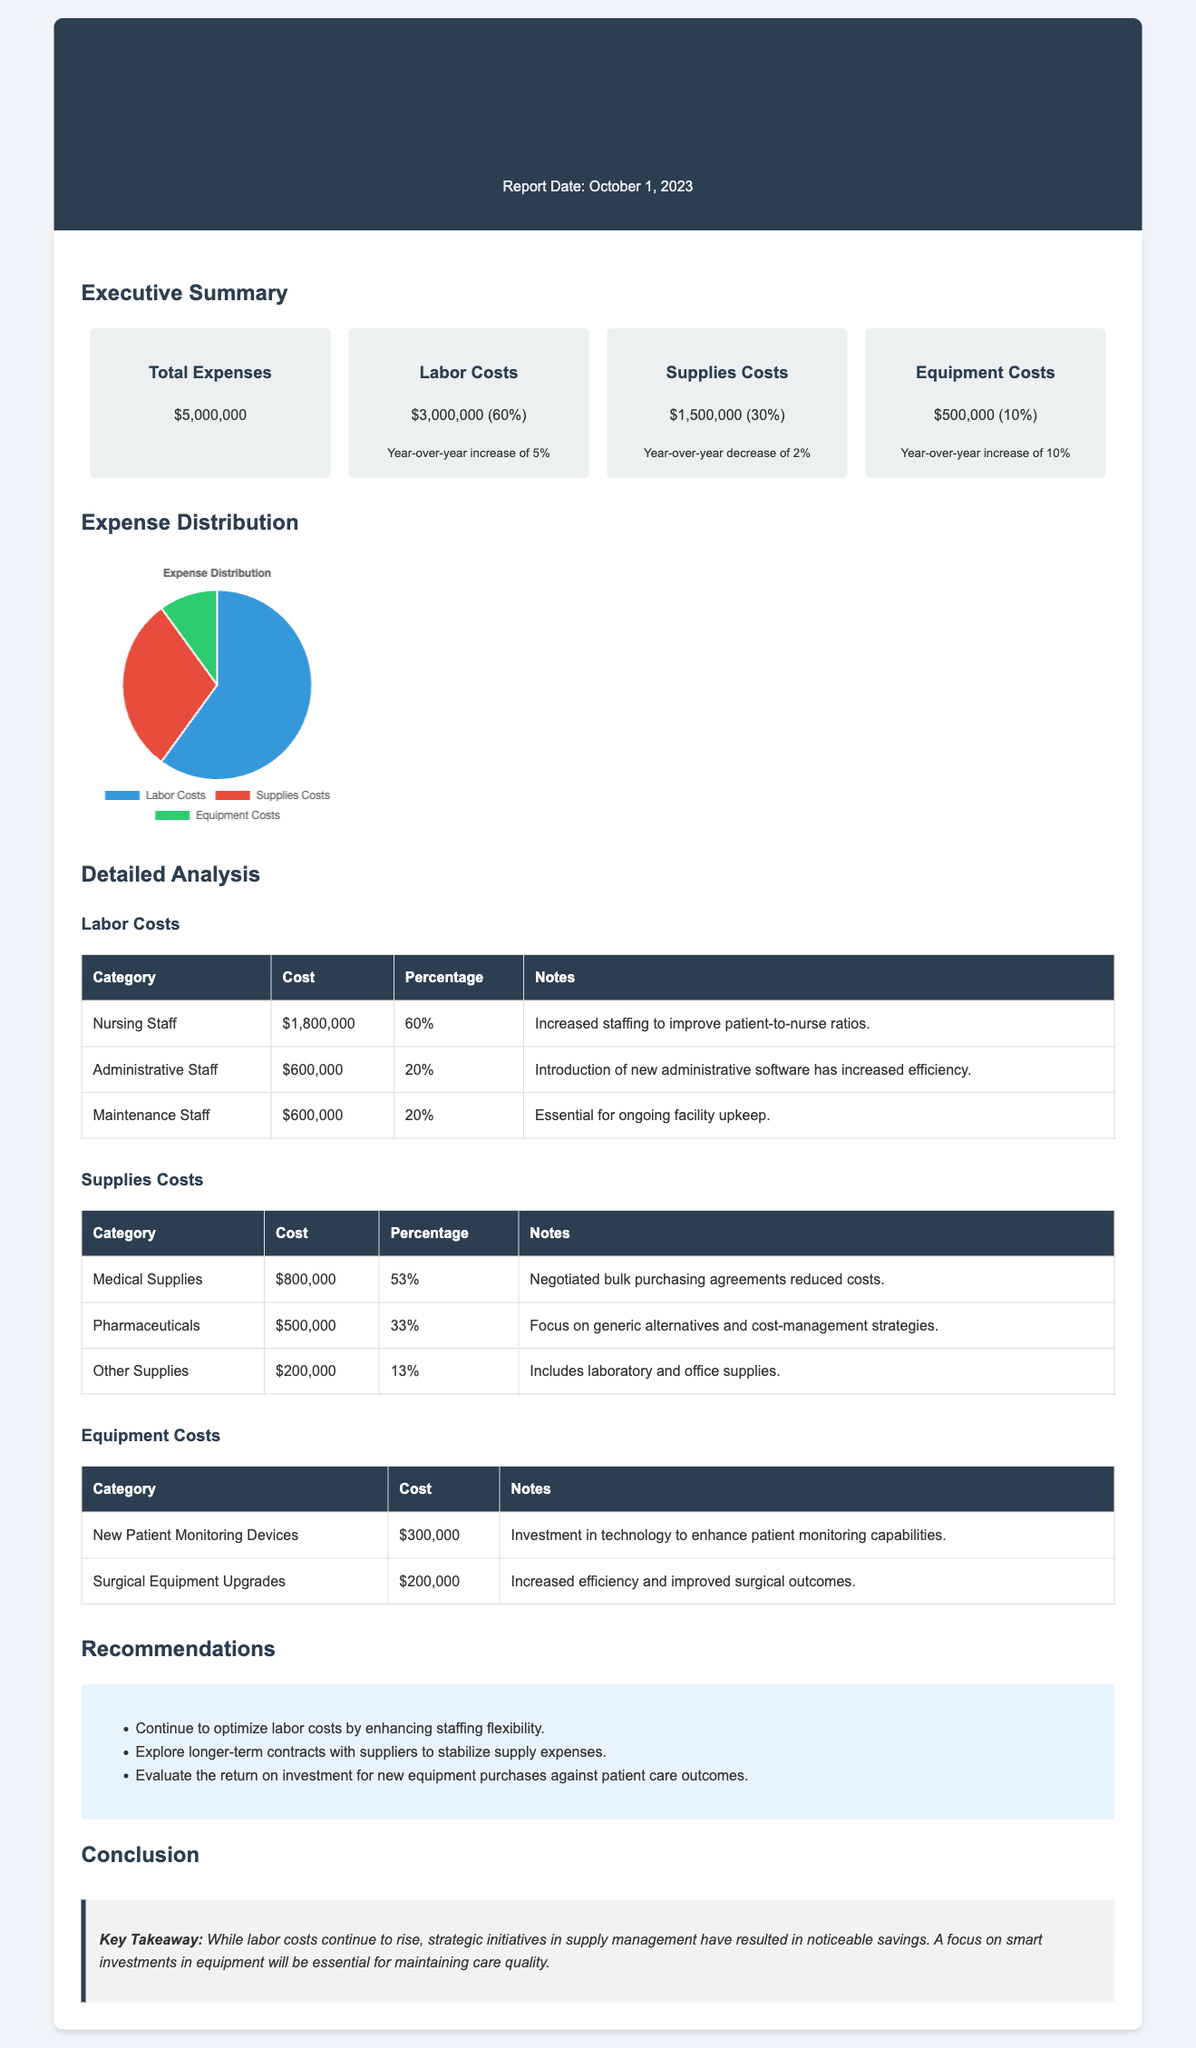what is the total expense? The total expense is clearly stated in the executive summary section of the document.
Answer: $5,000,000 what are the labor costs? The labor costs are detailed in the summary section with a specific amount and year-over-year change.
Answer: $3,000,000 (60%) what is the year-over-year change for supplies costs? The year-over-year change for supplies costs is mentioned in the summary, indicating an increase or decrease.
Answer: decrease of 2% which category has the highest cost in labor costs? The detailed analysis of labor costs breaks down the costs by category, indicating which has the highest expense.
Answer: Nursing Staff what was the investment amount for new patient monitoring devices? The equipment costs section lists specific costs for each equipment category, including new patient monitoring devices.
Answer: $300,000 what recommendation is made for supply expenses? The recommendations section provides guidance on managing supply costs, directly addressing supply expenses.
Answer: Explore longer-term contracts how much did the hospital spend on surgical equipment upgrades? The equipment costs table provides specific amounts for each item, including surgical equipment upgrades.
Answer: $200,000 what percentage of total expenses are attributed to equipment costs? The executive summary outlines the percentage distribution of costs across categories.
Answer: 10% what is the key takeaway from the conclusion? The conclusion summarizes the essential insights from the report, providing a critical view of the expenses discussed.
Answer: While labor costs continue to rise, strategic initiatives in supply management have resulted in noticeable savings 